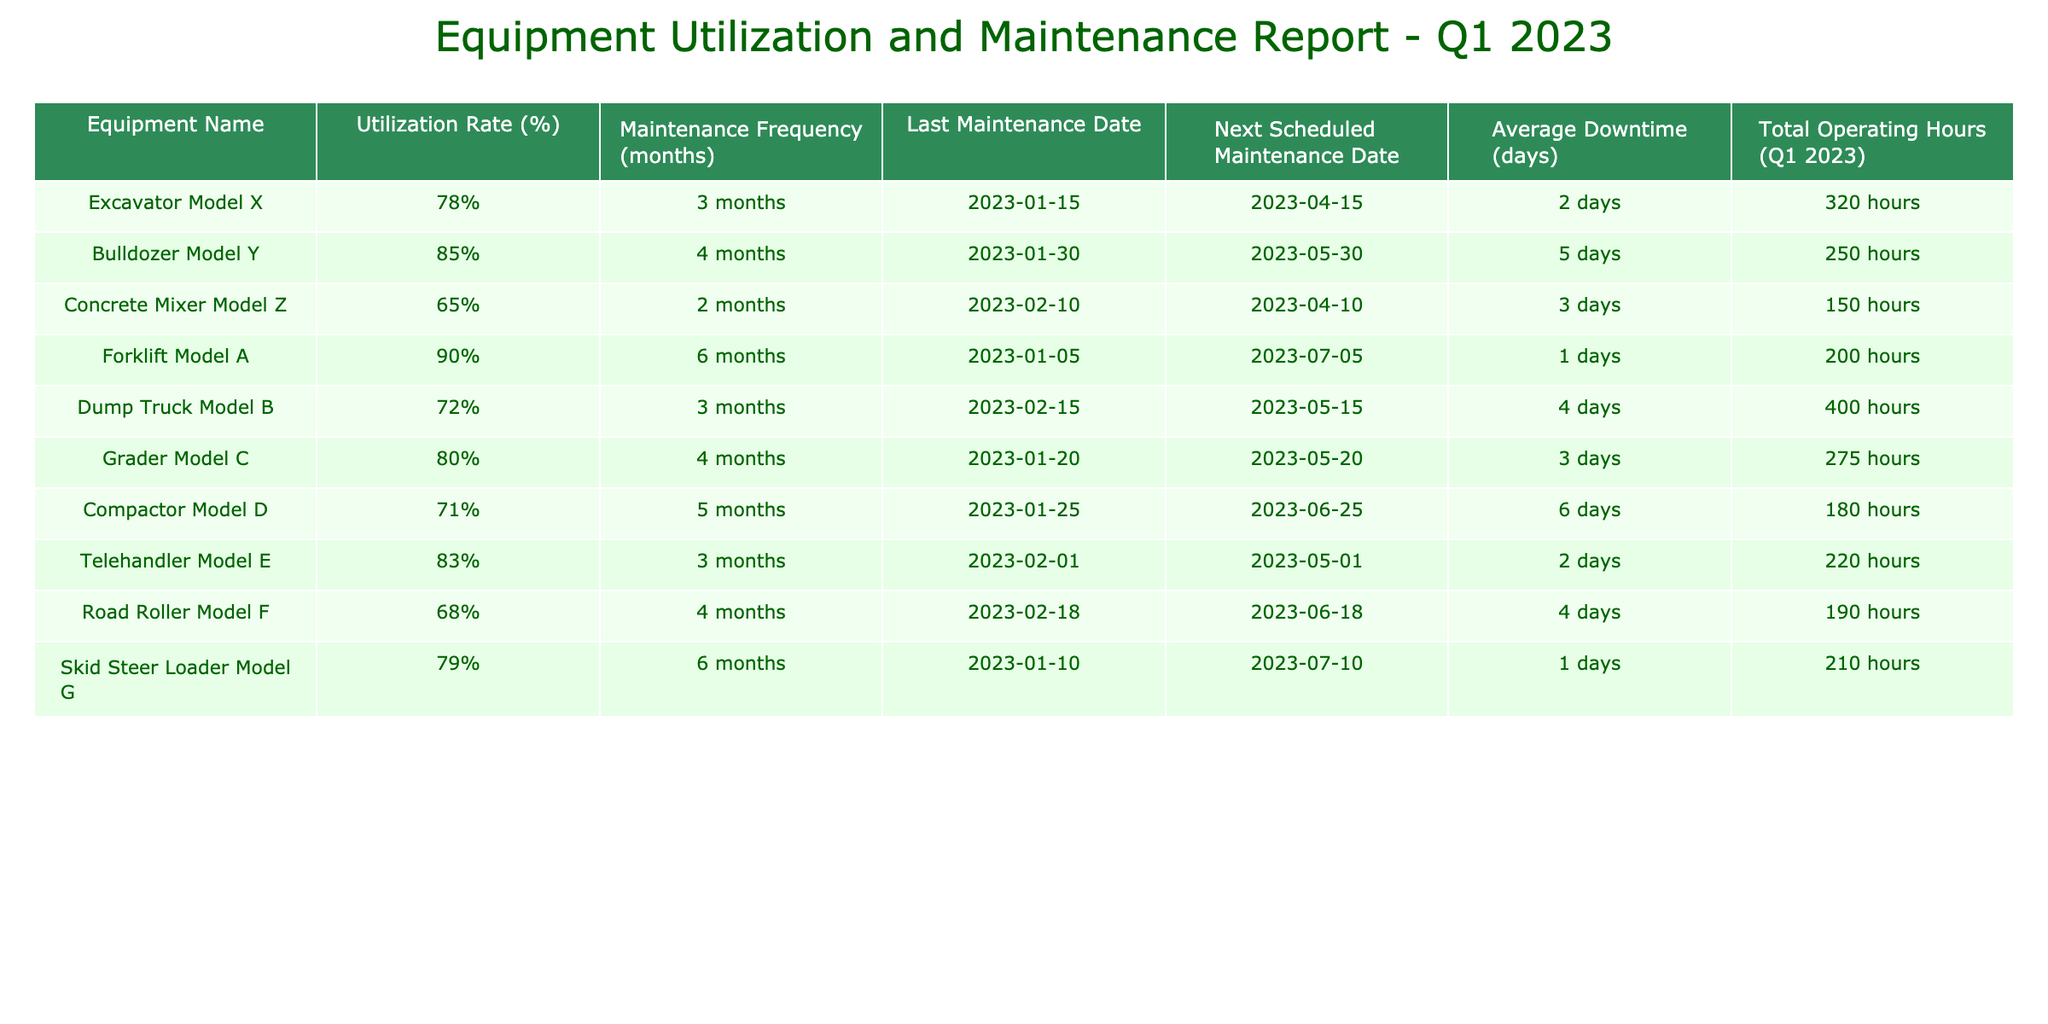What is the utilization rate of the Forklift Model A? The table directly shows that the Forklift Model A has a utilization rate of 90%.
Answer: 90% Which equipment has the highest average downtime in days? To find the highest average downtime, we compare the average downtime values for all equipment listed. The Compactor Model D has the highest average downtime listed as 6 days.
Answer: Compactor Model D What are the total operating hours for the Excavator Model X and the Dump Truck Model B combined? The total operating hours for the Excavator Model X is 320 hours, and for the Dump Truck Model B, it is 400 hours. Adding these together gives 320 + 400 = 720 hours.
Answer: 720 hours Is the maintenance frequency for the Telehandler Model E more than 3 months? The maintenance frequency for the Telehandler Model E is 3 months, which is not more than 3 months. Therefore, the answer is no.
Answer: No Which equipment's next scheduled maintenance is the soonest after Q1 2023? We check the next scheduled maintenance dates for all equipment: April 15 (Excavator Model X), May 1 (Telehandler Model E), May 15 (Dump Truck Model B), May 20 (Grader Model C), May 30 (Bulldozer Model Y), June 18 (Road Roller Model F), and June 25 (Compactor Model D). The Excavator Model X has the soonest next scheduled maintenance on April 15.
Answer: Excavator Model X What is the average utilization rate of all equipment listed in Q1 2023? To find the average, we add all the utilization rates: 78 + 85 + 65 + 90 + 72 + 80 + 71 + 83 + 68 + 79, which equals 800. Then, we divide by the number of equipment (10): 800 / 10 = 80%.
Answer: 80% True or False: The Concrete Mixer Model Z has a utilization rate above 70%. The table shows that the Concrete Mixer Model Z has a utilization rate of 65%, which is below 70%. Therefore, the statement is false.
Answer: False Which equipment has the least total operating hours during Q1 2023? The total operating hours for each equipment are: Excavator Model X (320), Bulldozer Model Y (250), Concrete Mixer Model Z (150), Forklift Model A (200), Dump Truck Model B (400), Grader Model C (275), Compactor Model D (180), Telehandler Model E (220), Road Roller Model F (190), and Skid Steer Loader Model G (210). The Concrete Mixer Model Z has the least at 150 hours.
Answer: Concrete Mixer Model Z 